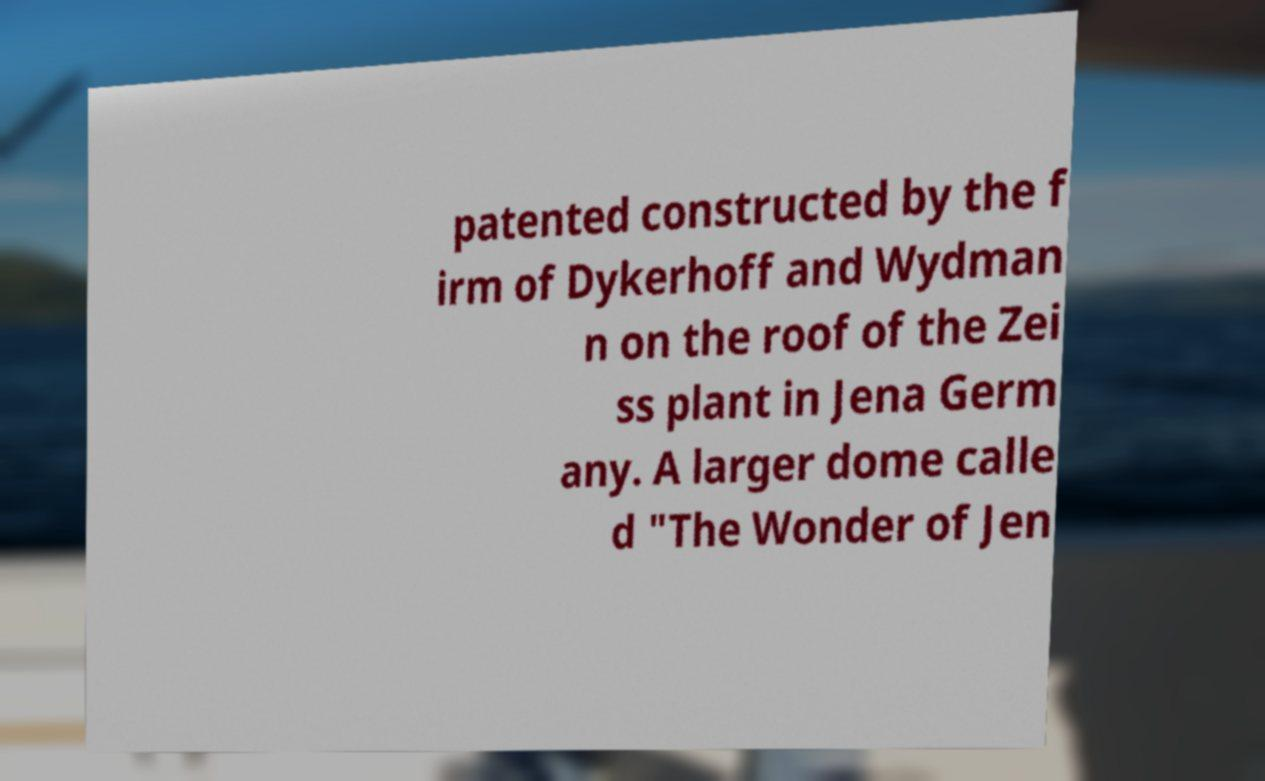There's text embedded in this image that I need extracted. Can you transcribe it verbatim? patented constructed by the f irm of Dykerhoff and Wydman n on the roof of the Zei ss plant in Jena Germ any. A larger dome calle d "The Wonder of Jen 